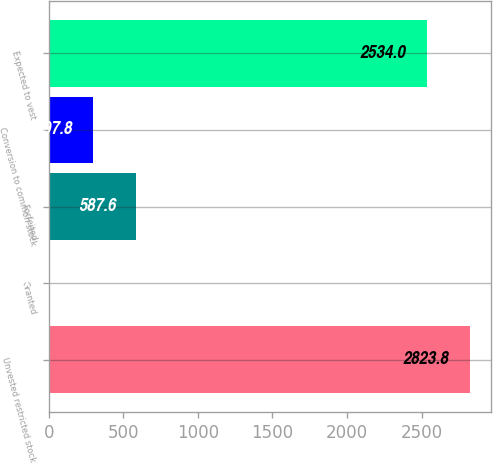<chart> <loc_0><loc_0><loc_500><loc_500><bar_chart><fcel>Unvested restricted stock<fcel>Granted<fcel>Forfeited<fcel>Conversion to common stock<fcel>Expected to vest<nl><fcel>2823.8<fcel>8<fcel>587.6<fcel>297.8<fcel>2534<nl></chart> 